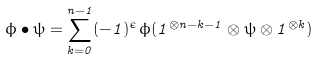<formula> <loc_0><loc_0><loc_500><loc_500>\phi \bullet \psi = \sum _ { k = 0 } ^ { n - 1 } ( - 1 ) ^ { \epsilon } \phi ( 1 ^ { \otimes n - k - 1 } \otimes \psi \otimes 1 ^ { \otimes k } )</formula> 